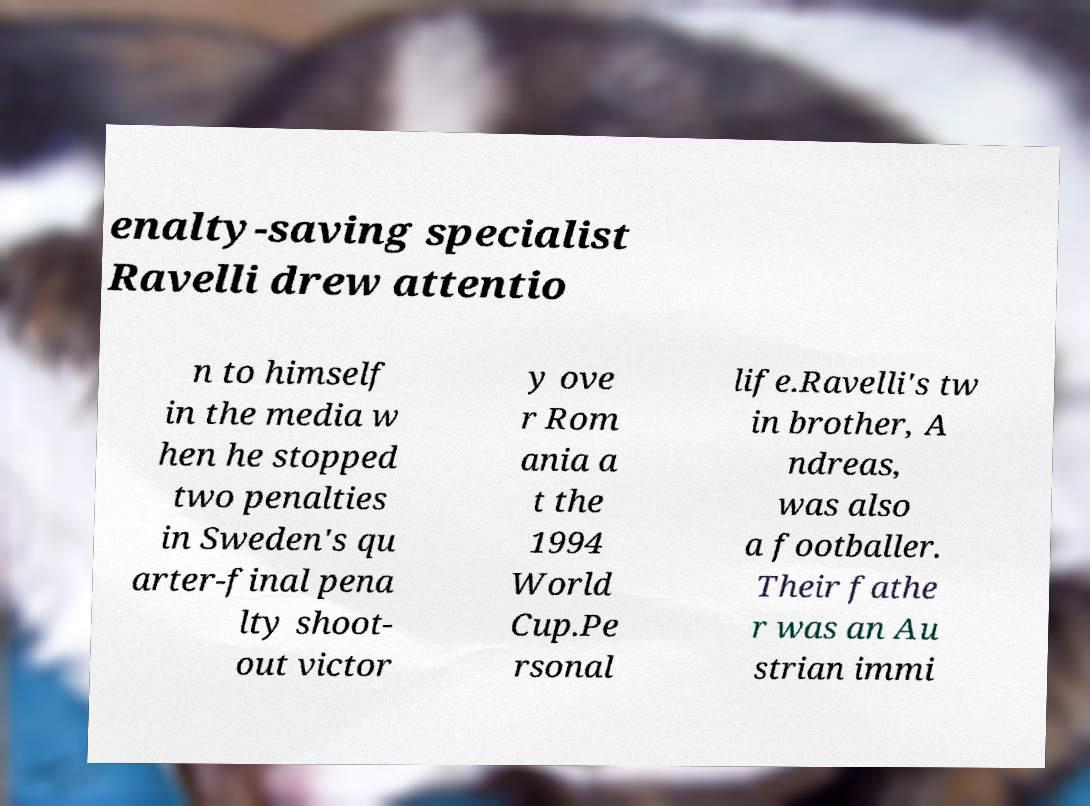Can you accurately transcribe the text from the provided image for me? enalty-saving specialist Ravelli drew attentio n to himself in the media w hen he stopped two penalties in Sweden's qu arter-final pena lty shoot- out victor y ove r Rom ania a t the 1994 World Cup.Pe rsonal life.Ravelli's tw in brother, A ndreas, was also a footballer. Their fathe r was an Au strian immi 